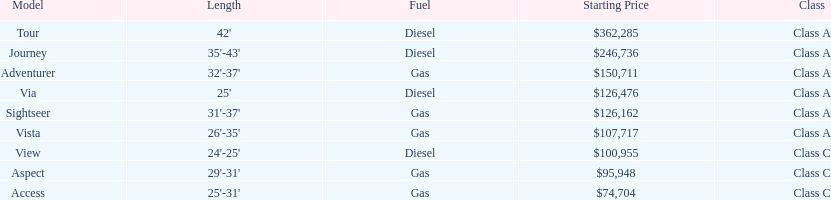Which model had the highest starting price Tour. 